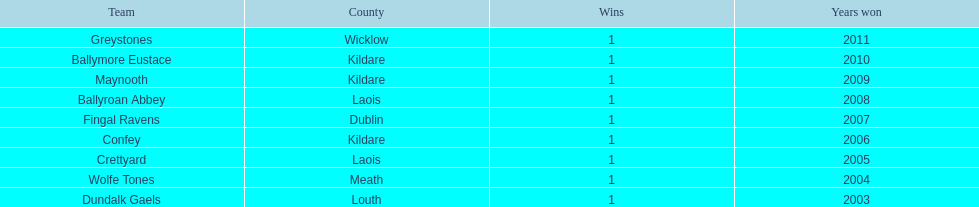What is the number of wins for greystones? 1. 